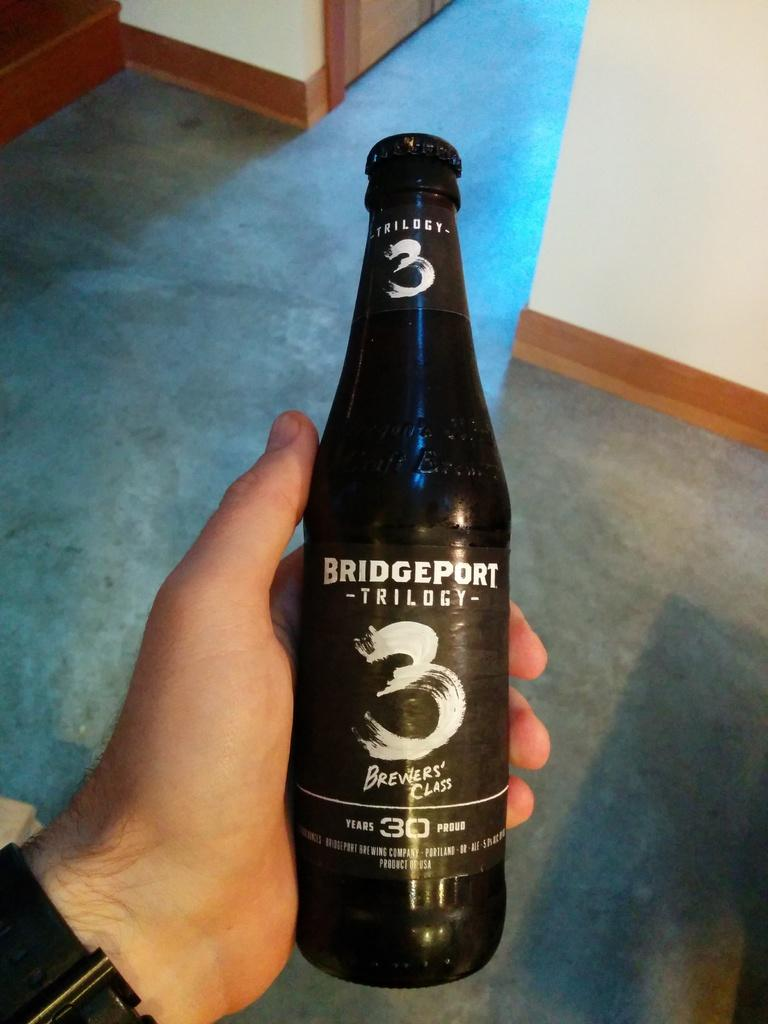Provide a one-sentence caption for the provided image. A bottle of Bridgeport Brewing Company Trilogy 3 alcoholic beverage. 